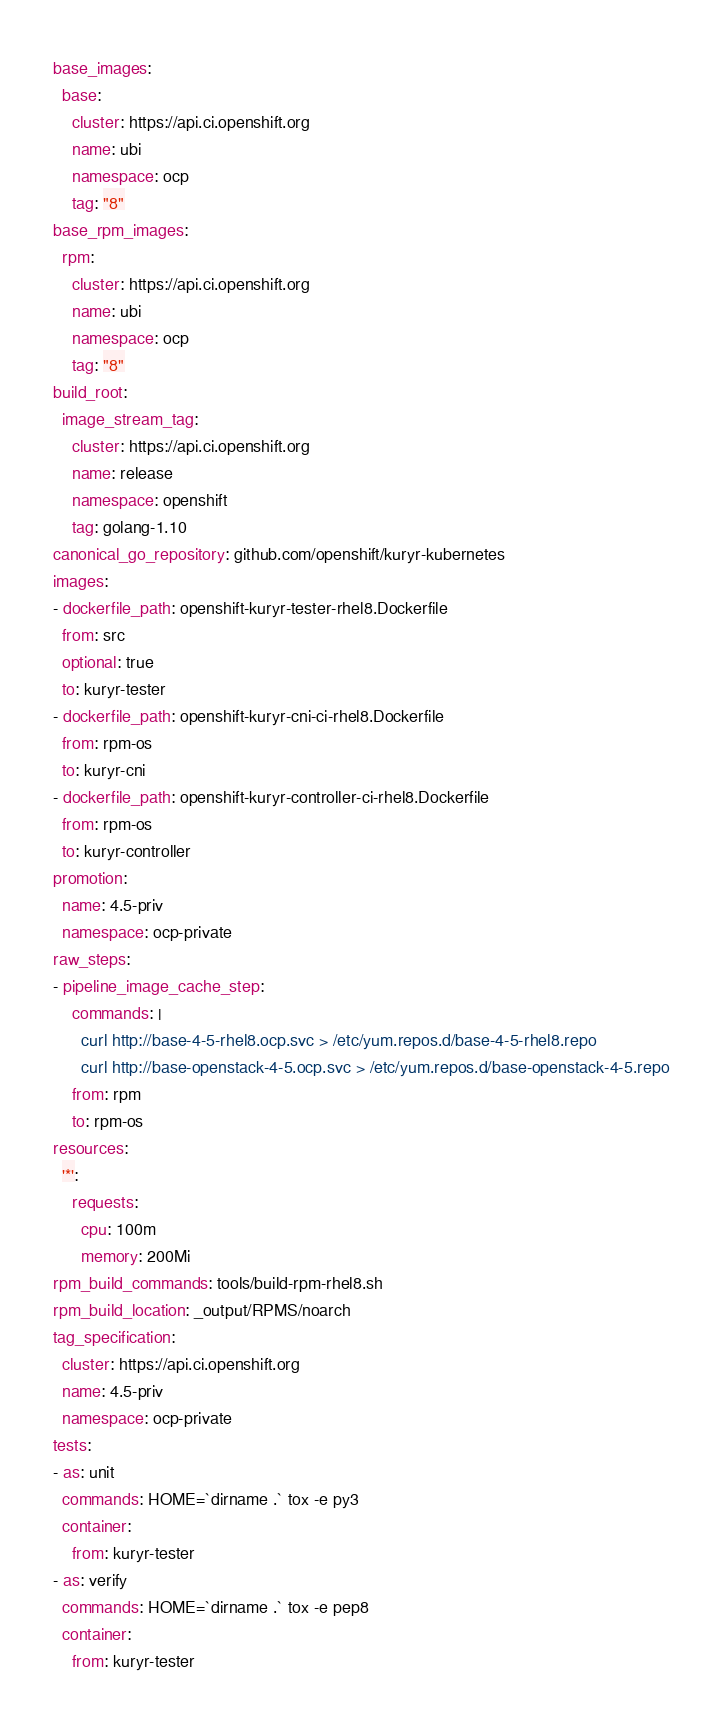<code> <loc_0><loc_0><loc_500><loc_500><_YAML_>base_images:
  base:
    cluster: https://api.ci.openshift.org
    name: ubi
    namespace: ocp
    tag: "8"
base_rpm_images:
  rpm:
    cluster: https://api.ci.openshift.org
    name: ubi
    namespace: ocp
    tag: "8"
build_root:
  image_stream_tag:
    cluster: https://api.ci.openshift.org
    name: release
    namespace: openshift
    tag: golang-1.10
canonical_go_repository: github.com/openshift/kuryr-kubernetes
images:
- dockerfile_path: openshift-kuryr-tester-rhel8.Dockerfile
  from: src
  optional: true
  to: kuryr-tester
- dockerfile_path: openshift-kuryr-cni-ci-rhel8.Dockerfile
  from: rpm-os
  to: kuryr-cni
- dockerfile_path: openshift-kuryr-controller-ci-rhel8.Dockerfile
  from: rpm-os
  to: kuryr-controller
promotion:
  name: 4.5-priv
  namespace: ocp-private
raw_steps:
- pipeline_image_cache_step:
    commands: |
      curl http://base-4-5-rhel8.ocp.svc > /etc/yum.repos.d/base-4-5-rhel8.repo
      curl http://base-openstack-4-5.ocp.svc > /etc/yum.repos.d/base-openstack-4-5.repo
    from: rpm
    to: rpm-os
resources:
  '*':
    requests:
      cpu: 100m
      memory: 200Mi
rpm_build_commands: tools/build-rpm-rhel8.sh
rpm_build_location: _output/RPMS/noarch
tag_specification:
  cluster: https://api.ci.openshift.org
  name: 4.5-priv
  namespace: ocp-private
tests:
- as: unit
  commands: HOME=`dirname .` tox -e py3
  container:
    from: kuryr-tester
- as: verify
  commands: HOME=`dirname .` tox -e pep8
  container:
    from: kuryr-tester
</code> 